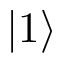Convert formula to latex. <formula><loc_0><loc_0><loc_500><loc_500>| { 1 } \rangle</formula> 